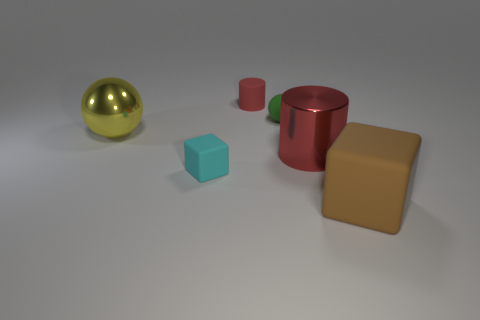Can you describe the textures of the objects seen here? Certainly! The objects in the image appear to have a matte finish with subtle reflections, indicating a non-glossy texture. Each object seems smooth without any visible roughness or patterning on their surface. 